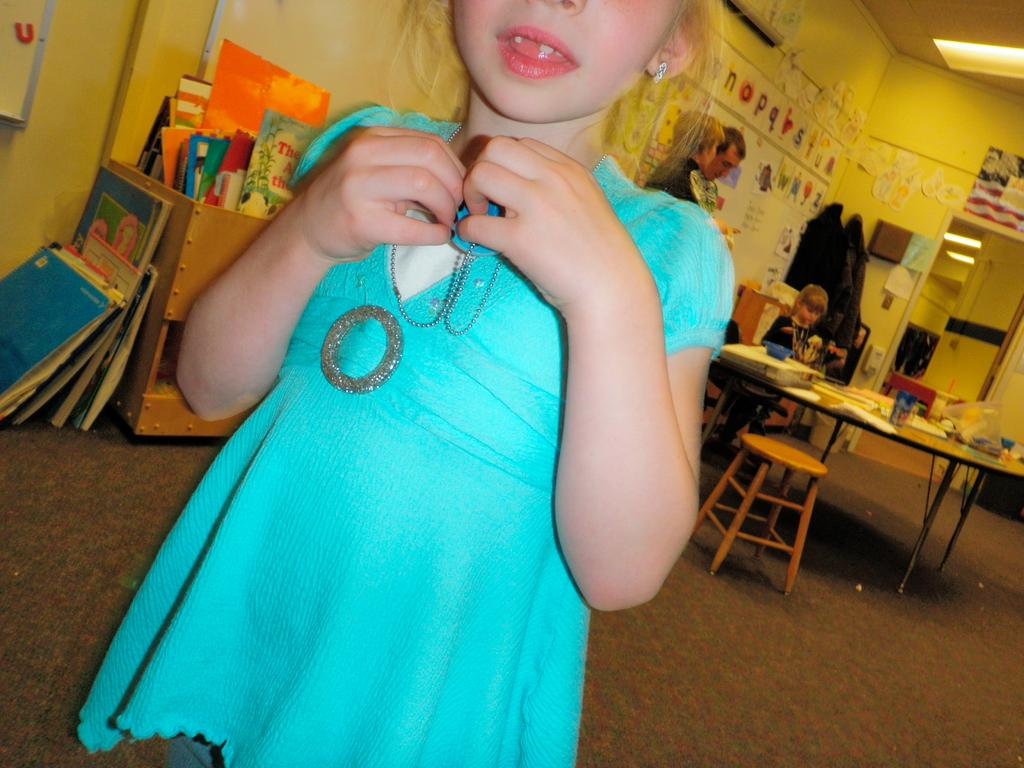What is the main subject of the image? There is a girl standing in the image. Are there any other people visible in the image? Yes, there are two people standing in the background of the image. What is the seated girl doing in the image? There is a girl seated on a chair in the image. What items can be seen on the table in the image? There are papers on a table in the image. What type of furniture is visible in the image? There is a bookshelf visible in the image. What type of road can be seen in the image? There is no road visible in the image. 